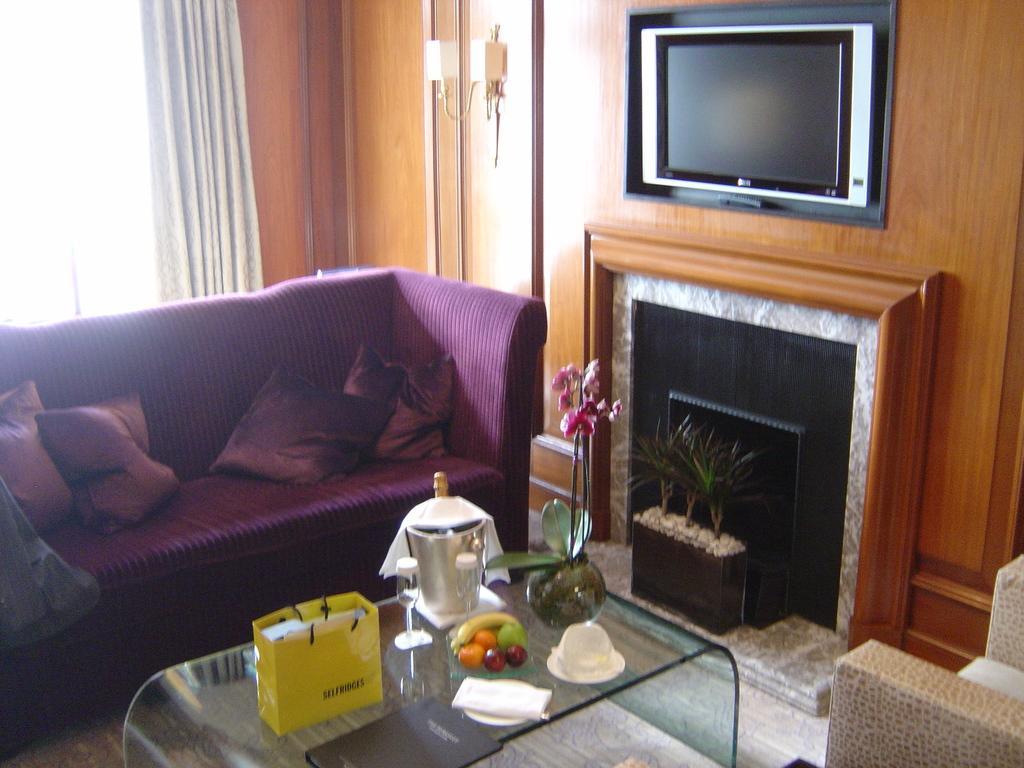Could you give a brief overview of what you see in this image? This is an inside view. n this image I can see a couch on the left side. In front of the couch there is a table. On the table some fruits, bag, glasses and one flower pot are arranged. On the top of the image there is a television on the table. At the back of the couch there is a window with a white curtain. 